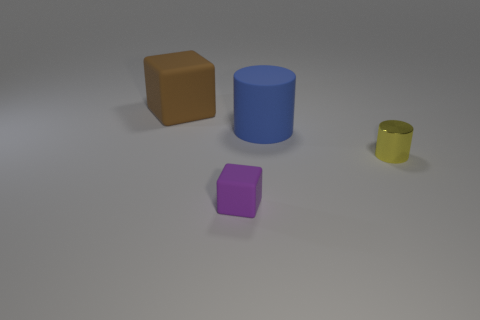What could these objects represent in a symbolic way? The objects can symbolize a variety of concepts. The cubes might represent stability and uniformity, while the cylinders could symbolize continuity and the flow of time. The varying sizes may suggest different magnitudes or levels of impact within the concepts they represent. Could these objects be used to explain any scientific concept? Yes, they could be used to help visualize different scientific concepts. For example, they might represent molecular structures in chemistry, geometric shapes in mathematics, or simple machines in physics, such as cylinders exemplifying rollers. 